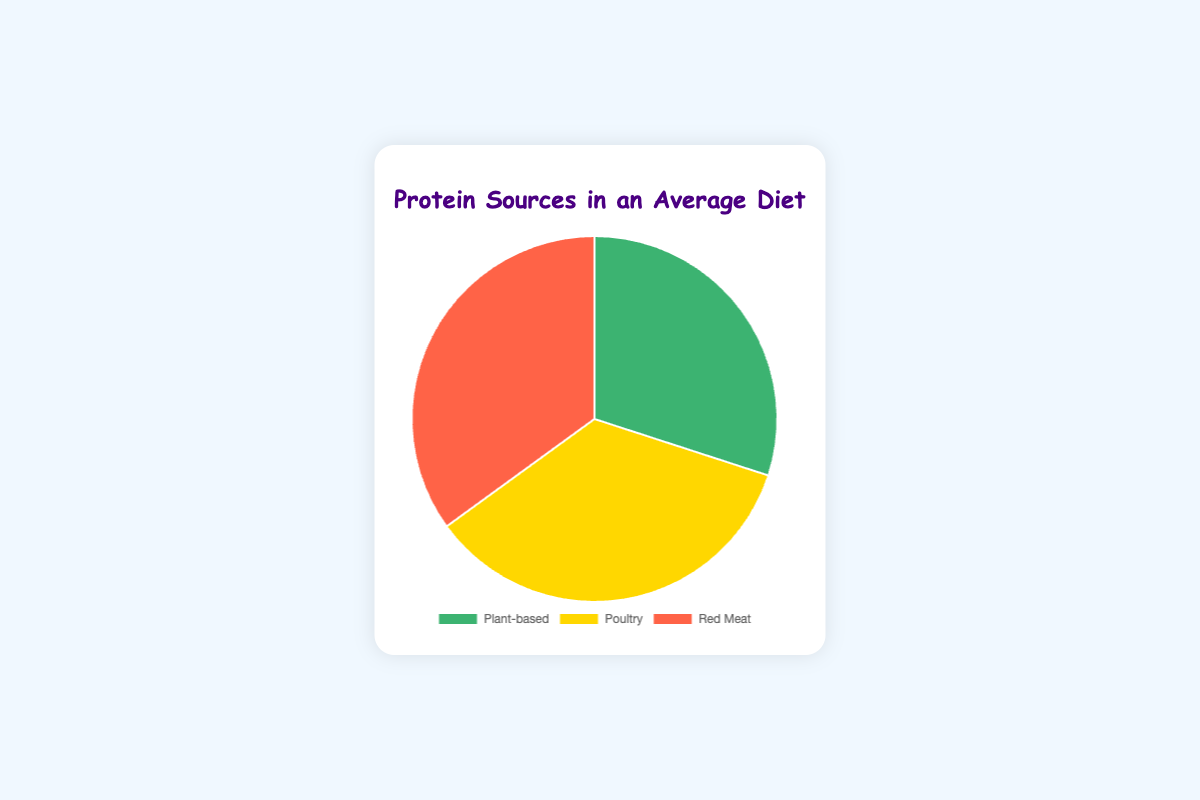how many percentage points more does poultry contribute to protein intake compared to plant-based sources? Poultry contributes 35%, and plant-based sources contribute 30%. The difference is 35% - 30% = 5%.
Answer: 5 percentage points which protein source has the same percentage of intake as red meat? The protein source with the same percentage of intake as red meat, which is 35%, is poultry.
Answer: Poultry if plant-based intake increased by 10%, what would be its new percentage? If the plant-based intake increases by 10%, the new percentage would be 30% + 10% = 40%.
Answer: 40% is the intake from red meat greater than, less than, or equal to the intake from poultry? The intake from red meat is equal to the intake from poultry; both are 35%.
Answer: Equal what is the combined percentage of protein intake from poultry and red meat? The combined percentage of poultry and red meat is 35% + 35% = 70%.
Answer: 70% which section of the pie chart is colored green? The section colored green represents plant-based protein sources.
Answer: Plant-based what percentage of protein intake comes from non-red meat sources? The percentage of protein intake from non-red meat sources is the sum of plant-based and poultry intake, which is 30% + 35% = 65%.
Answer: 65% if the percentage of plant-based intake doubled, what would be the percentage distribution of all sources if the total percentage is normalized back to 100%? If plant-based intake doubles, its percentage becomes 60%. The new total percentage is 60% + 35% + 35% = 130%. To normalize, you divide each percentage by 130%:
   - Plant-based: 60% / 130% * 100% ≈ 46.15%
   - Poultry: 35% / 130% * 100% ≈ 26.92%
   - Red Meat: 35% / 130% * 100% ≈ 26.92%
Since 46.15% + 26.92% + 26.92% = 100%, the normalized percentages are correct.
Answer: Plant-based: 46.15%, Poultry: 26.92%, Red Meat: 26.92% what color represents the largest segment in the pie chart? The largest segments are equal in size and the colors representing the largest segments are yellow for poultry and red for red meat, both at 35%.
Answer: Yellow and Red 